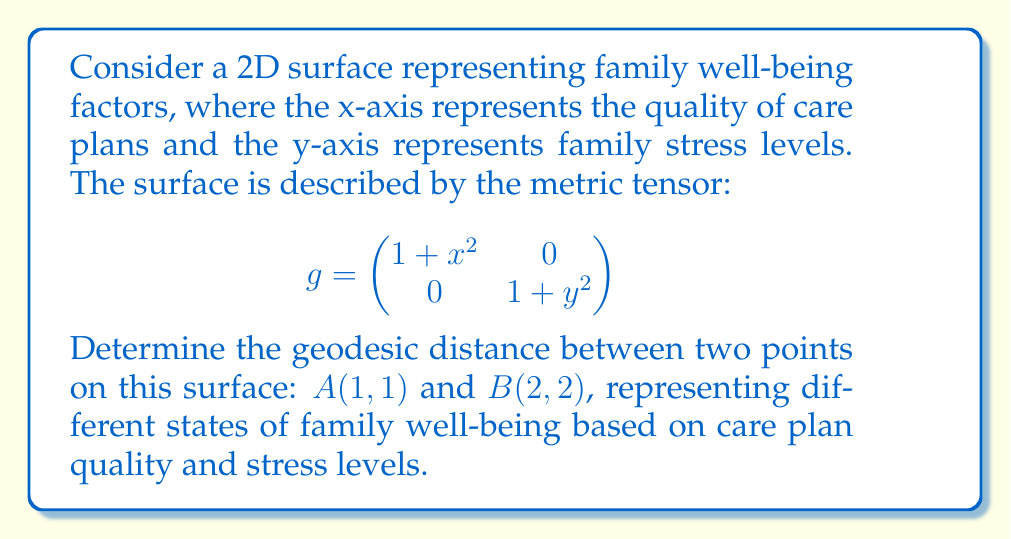Can you solve this math problem? To find the geodesic distance between two points on a surface, we need to solve the geodesic equation. However, for this specific metric, we can use a simpler approach:

1) The geodesic between two points on this surface is a straight line in the parameter space. We can parameterize this line as:

   $x(t) = 1 + t$
   $y(t) = 1 + t$
   where $0 \leq t \leq 1$

2) The infinitesimal arc length is given by:
   
   $$ds^2 = g_{11}dx^2 + g_{22}dy^2 = (1+x^2)dx^2 + (1+y^2)dy^2$$

3) Substituting our parameterization:

   $$ds^2 = (1+(1+t)^2)dt^2 + (1+(1+t)^2)dt^2 = 2(2+2t+t^2)dt^2$$

4) The total arc length (geodesic distance) is then:

   $$s = \int_0^1 \sqrt{2(2+2t+t^2)} dt$$

5) This integral can be solved using the substitution $u = t + 1$:

   $$s = \sqrt{2} \int_1^2 \sqrt{1+u^2} du$$

6) The result of this integral is:

   $$s = \sqrt{2} \left[ \frac{u}{2}\sqrt{1+u^2} + \frac{1}{2}\ln(u+\sqrt{1+u^2}) \right]_1^2$$

7) Evaluating the bounds:

   $$s = \sqrt{2} \left[ (\sqrt{5} + \ln(2+\sqrt{5})) - (\frac{\sqrt{2}}{2} + \frac{1}{2}\ln(1+\sqrt{2})) \right]$$
Answer: $\sqrt{2} \left[ (\sqrt{5} + \ln(2+\sqrt{5})) - (\frac{\sqrt{2}}{2} + \frac{1}{2}\ln(1+\sqrt{2})) \right]$ 